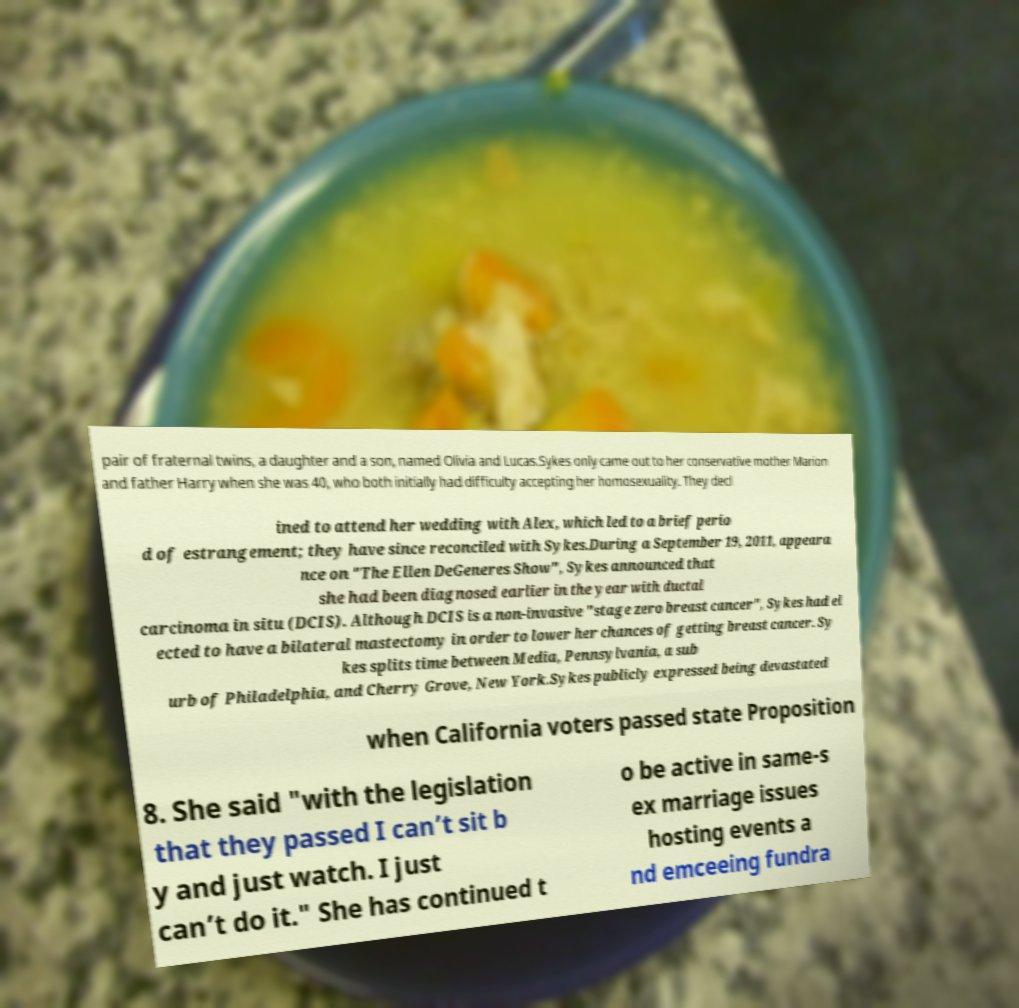For documentation purposes, I need the text within this image transcribed. Could you provide that? pair of fraternal twins, a daughter and a son, named Olivia and Lucas.Sykes only came out to her conservative mother Marion and father Harry when she was 40, who both initially had difficulty accepting her homosexuality. They decl ined to attend her wedding with Alex, which led to a brief perio d of estrangement; they have since reconciled with Sykes.During a September 19, 2011, appeara nce on "The Ellen DeGeneres Show", Sykes announced that she had been diagnosed earlier in the year with ductal carcinoma in situ (DCIS). Although DCIS is a non-invasive "stage zero breast cancer", Sykes had el ected to have a bilateral mastectomy in order to lower her chances of getting breast cancer. Sy kes splits time between Media, Pennsylvania, a sub urb of Philadelphia, and Cherry Grove, New York.Sykes publicly expressed being devastated when California voters passed state Proposition 8. She said "with the legislation that they passed I can’t sit b y and just watch. I just can’t do it." She has continued t o be active in same-s ex marriage issues hosting events a nd emceeing fundra 